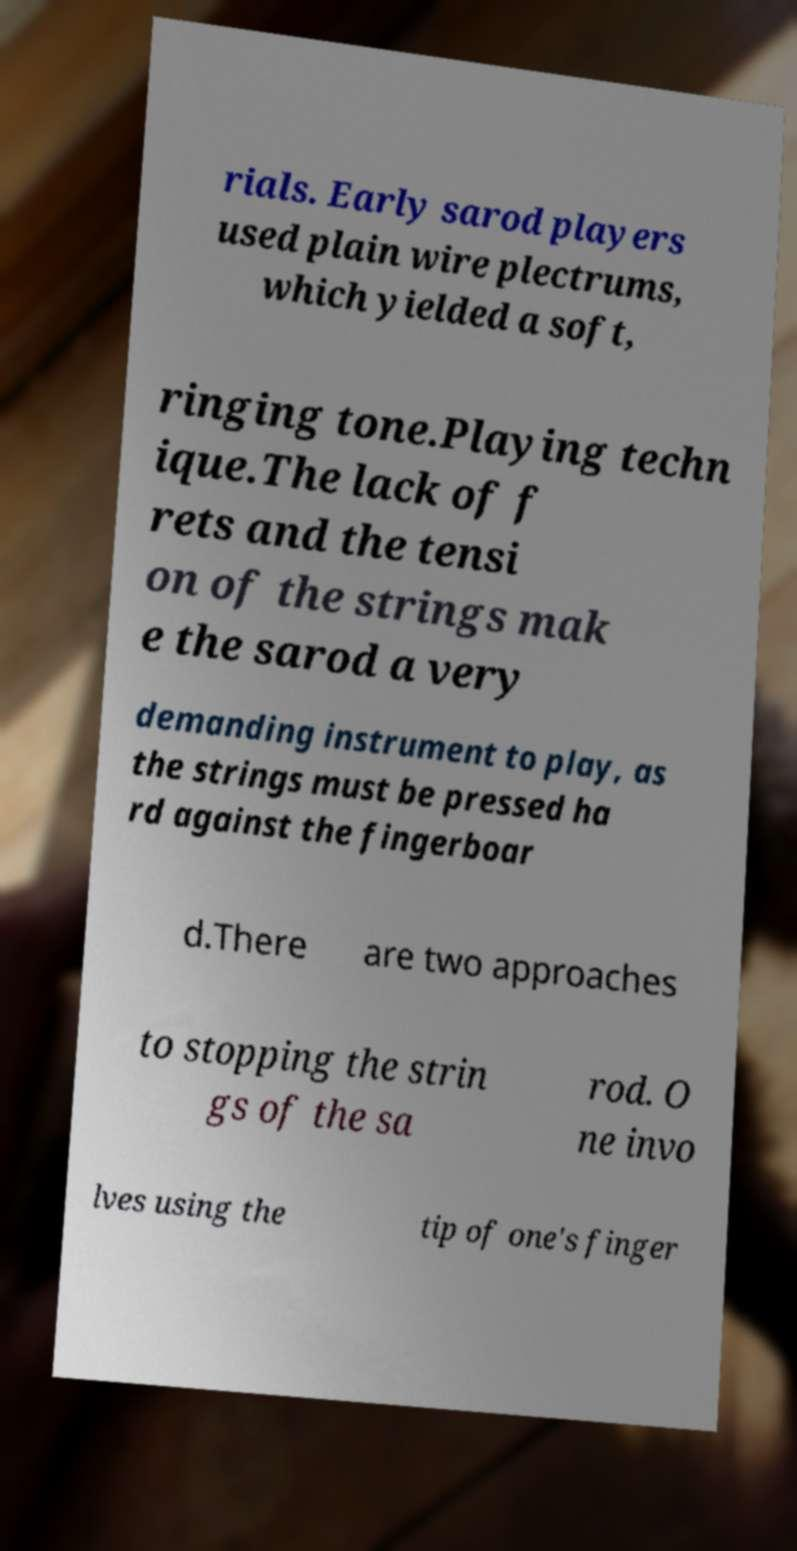Can you accurately transcribe the text from the provided image for me? rials. Early sarod players used plain wire plectrums, which yielded a soft, ringing tone.Playing techn ique.The lack of f rets and the tensi on of the strings mak e the sarod a very demanding instrument to play, as the strings must be pressed ha rd against the fingerboar d.There are two approaches to stopping the strin gs of the sa rod. O ne invo lves using the tip of one's finger 